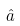<formula> <loc_0><loc_0><loc_500><loc_500>\hat { a }</formula> 